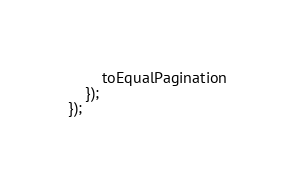<code> <loc_0><loc_0><loc_500><loc_500><_TypeScript_>        toEqualPagination
    });
});
</code> 